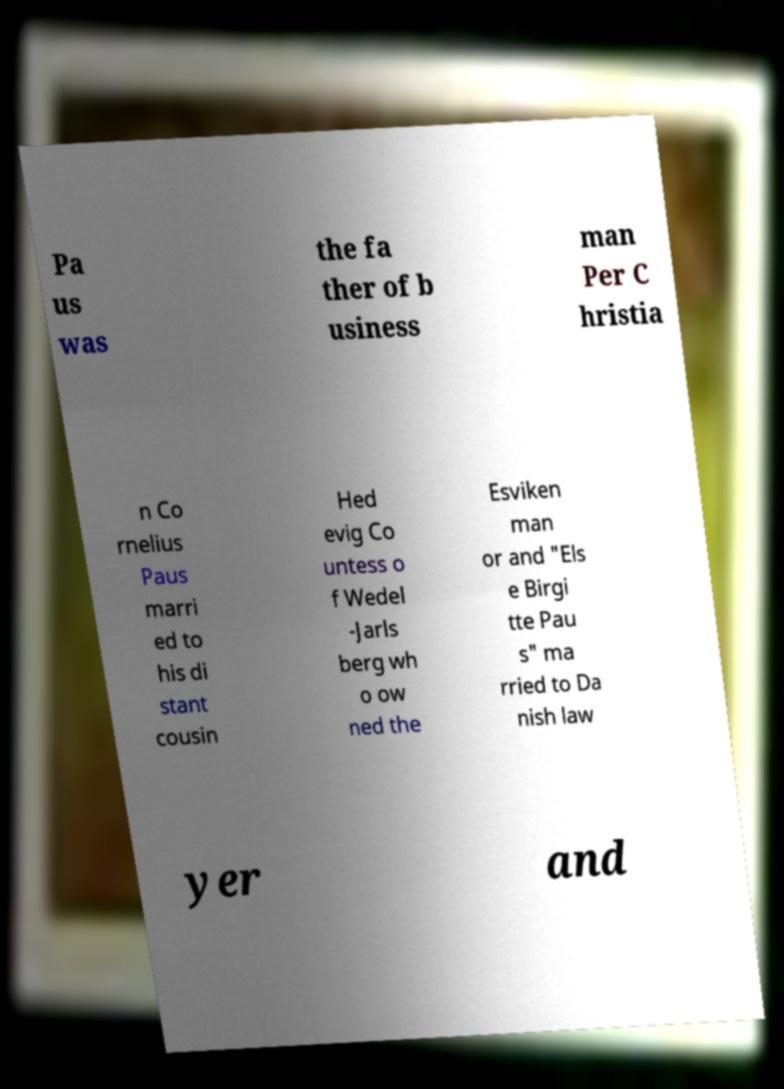Could you extract and type out the text from this image? Pa us was the fa ther of b usiness man Per C hristia n Co rnelius Paus marri ed to his di stant cousin Hed evig Co untess o f Wedel -Jarls berg wh o ow ned the Esviken man or and "Els e Birgi tte Pau s" ma rried to Da nish law yer and 